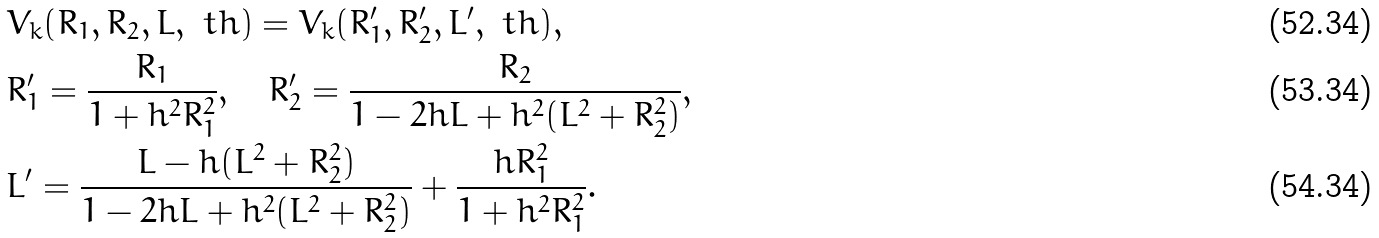<formula> <loc_0><loc_0><loc_500><loc_500>& V _ { k } ( R _ { 1 } , R _ { 2 } , L , \ t h ) = V _ { k } ( R _ { 1 } ^ { \prime } , R _ { 2 } ^ { \prime } , L ^ { \prime } , \ t h ) , \\ & R _ { 1 } ^ { \prime } = \frac { R _ { 1 } } { 1 + h ^ { 2 } R _ { 1 } ^ { 2 } } , \quad R _ { 2 } ^ { \prime } = \frac { R _ { 2 } } { 1 - 2 h L + h ^ { 2 } ( L ^ { 2 } + R _ { 2 } ^ { 2 } ) } , \\ & L ^ { \prime } = \frac { L - h ( L ^ { 2 } + R _ { 2 } ^ { 2 } ) } { 1 - 2 h L + h ^ { 2 } ( L ^ { 2 } + R _ { 2 } ^ { 2 } ) } + \frac { h R _ { 1 } ^ { 2 } } { 1 + h ^ { 2 } R _ { 1 } ^ { 2 } } .</formula> 